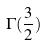Convert formula to latex. <formula><loc_0><loc_0><loc_500><loc_500>\Gamma ( \frac { 3 } { 2 } )</formula> 